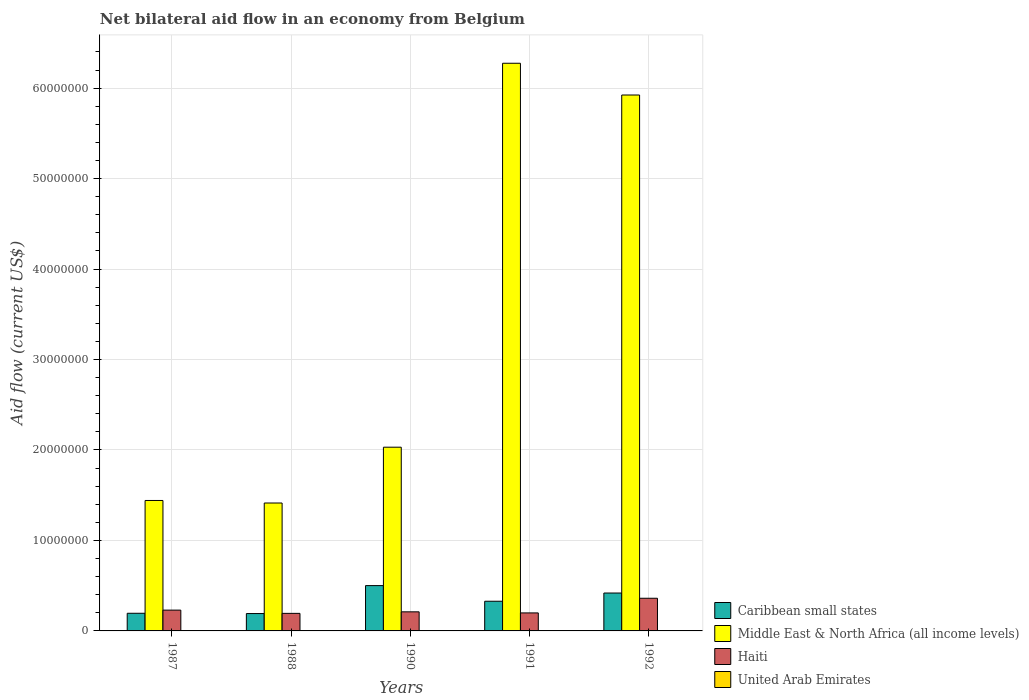How many groups of bars are there?
Offer a terse response. 5. Are the number of bars per tick equal to the number of legend labels?
Provide a succinct answer. Yes. Are the number of bars on each tick of the X-axis equal?
Offer a very short reply. Yes. How many bars are there on the 5th tick from the right?
Your answer should be very brief. 4. In how many cases, is the number of bars for a given year not equal to the number of legend labels?
Make the answer very short. 0. Across all years, what is the minimum net bilateral aid flow in Middle East & North Africa (all income levels)?
Provide a succinct answer. 1.41e+07. In which year was the net bilateral aid flow in United Arab Emirates maximum?
Your response must be concise. 1992. In which year was the net bilateral aid flow in Middle East & North Africa (all income levels) minimum?
Your answer should be very brief. 1988. What is the difference between the net bilateral aid flow in Caribbean small states in 1987 and that in 1992?
Provide a succinct answer. -2.24e+06. What is the difference between the net bilateral aid flow in Middle East & North Africa (all income levels) in 1988 and the net bilateral aid flow in Caribbean small states in 1991?
Provide a succinct answer. 1.09e+07. What is the average net bilateral aid flow in Caribbean small states per year?
Your response must be concise. 3.27e+06. In the year 1991, what is the difference between the net bilateral aid flow in Caribbean small states and net bilateral aid flow in Haiti?
Give a very brief answer. 1.29e+06. In how many years, is the net bilateral aid flow in Haiti greater than 24000000 US$?
Provide a succinct answer. 0. What is the difference between the highest and the second highest net bilateral aid flow in Middle East & North Africa (all income levels)?
Ensure brevity in your answer.  3.51e+06. What is the difference between the highest and the lowest net bilateral aid flow in United Arab Emirates?
Provide a short and direct response. 2.00e+04. In how many years, is the net bilateral aid flow in Caribbean small states greater than the average net bilateral aid flow in Caribbean small states taken over all years?
Your answer should be compact. 3. Is it the case that in every year, the sum of the net bilateral aid flow in United Arab Emirates and net bilateral aid flow in Middle East & North Africa (all income levels) is greater than the sum of net bilateral aid flow in Haiti and net bilateral aid flow in Caribbean small states?
Your answer should be compact. Yes. What does the 4th bar from the left in 1987 represents?
Ensure brevity in your answer.  United Arab Emirates. What does the 4th bar from the right in 1990 represents?
Your answer should be compact. Caribbean small states. Is it the case that in every year, the sum of the net bilateral aid flow in Middle East & North Africa (all income levels) and net bilateral aid flow in United Arab Emirates is greater than the net bilateral aid flow in Haiti?
Ensure brevity in your answer.  Yes. How many years are there in the graph?
Provide a short and direct response. 5. What is the difference between two consecutive major ticks on the Y-axis?
Your response must be concise. 1.00e+07. Are the values on the major ticks of Y-axis written in scientific E-notation?
Give a very brief answer. No. Does the graph contain grids?
Make the answer very short. Yes. Where does the legend appear in the graph?
Offer a very short reply. Bottom right. What is the title of the graph?
Provide a succinct answer. Net bilateral aid flow in an economy from Belgium. Does "Burkina Faso" appear as one of the legend labels in the graph?
Your answer should be very brief. No. What is the Aid flow (current US$) in Caribbean small states in 1987?
Offer a very short reply. 1.95e+06. What is the Aid flow (current US$) in Middle East & North Africa (all income levels) in 1987?
Your response must be concise. 1.44e+07. What is the Aid flow (current US$) of Haiti in 1987?
Make the answer very short. 2.30e+06. What is the Aid flow (current US$) of United Arab Emirates in 1987?
Keep it short and to the point. 10000. What is the Aid flow (current US$) in Caribbean small states in 1988?
Provide a short and direct response. 1.92e+06. What is the Aid flow (current US$) in Middle East & North Africa (all income levels) in 1988?
Give a very brief answer. 1.41e+07. What is the Aid flow (current US$) of Haiti in 1988?
Offer a very short reply. 1.94e+06. What is the Aid flow (current US$) in United Arab Emirates in 1988?
Keep it short and to the point. 10000. What is the Aid flow (current US$) in Caribbean small states in 1990?
Your answer should be very brief. 5.01e+06. What is the Aid flow (current US$) in Middle East & North Africa (all income levels) in 1990?
Provide a succinct answer. 2.03e+07. What is the Aid flow (current US$) of Haiti in 1990?
Ensure brevity in your answer.  2.11e+06. What is the Aid flow (current US$) of United Arab Emirates in 1990?
Provide a short and direct response. 10000. What is the Aid flow (current US$) of Caribbean small states in 1991?
Offer a terse response. 3.28e+06. What is the Aid flow (current US$) of Middle East & North Africa (all income levels) in 1991?
Provide a succinct answer. 6.28e+07. What is the Aid flow (current US$) of Haiti in 1991?
Your answer should be very brief. 1.99e+06. What is the Aid flow (current US$) in Caribbean small states in 1992?
Keep it short and to the point. 4.19e+06. What is the Aid flow (current US$) in Middle East & North Africa (all income levels) in 1992?
Provide a short and direct response. 5.92e+07. What is the Aid flow (current US$) of Haiti in 1992?
Your answer should be compact. 3.61e+06. Across all years, what is the maximum Aid flow (current US$) of Caribbean small states?
Keep it short and to the point. 5.01e+06. Across all years, what is the maximum Aid flow (current US$) of Middle East & North Africa (all income levels)?
Your response must be concise. 6.28e+07. Across all years, what is the maximum Aid flow (current US$) of Haiti?
Your response must be concise. 3.61e+06. Across all years, what is the maximum Aid flow (current US$) in United Arab Emirates?
Ensure brevity in your answer.  3.00e+04. Across all years, what is the minimum Aid flow (current US$) of Caribbean small states?
Provide a short and direct response. 1.92e+06. Across all years, what is the minimum Aid flow (current US$) in Middle East & North Africa (all income levels)?
Your answer should be very brief. 1.41e+07. Across all years, what is the minimum Aid flow (current US$) in Haiti?
Provide a succinct answer. 1.94e+06. Across all years, what is the minimum Aid flow (current US$) in United Arab Emirates?
Provide a succinct answer. 10000. What is the total Aid flow (current US$) of Caribbean small states in the graph?
Offer a terse response. 1.64e+07. What is the total Aid flow (current US$) of Middle East & North Africa (all income levels) in the graph?
Give a very brief answer. 1.71e+08. What is the total Aid flow (current US$) of Haiti in the graph?
Give a very brief answer. 1.20e+07. What is the total Aid flow (current US$) of United Arab Emirates in the graph?
Offer a very short reply. 7.00e+04. What is the difference between the Aid flow (current US$) in Caribbean small states in 1987 and that in 1988?
Give a very brief answer. 3.00e+04. What is the difference between the Aid flow (current US$) in Haiti in 1987 and that in 1988?
Ensure brevity in your answer.  3.60e+05. What is the difference between the Aid flow (current US$) in United Arab Emirates in 1987 and that in 1988?
Make the answer very short. 0. What is the difference between the Aid flow (current US$) of Caribbean small states in 1987 and that in 1990?
Provide a short and direct response. -3.06e+06. What is the difference between the Aid flow (current US$) of Middle East & North Africa (all income levels) in 1987 and that in 1990?
Your answer should be very brief. -5.89e+06. What is the difference between the Aid flow (current US$) of Haiti in 1987 and that in 1990?
Provide a succinct answer. 1.90e+05. What is the difference between the Aid flow (current US$) in Caribbean small states in 1987 and that in 1991?
Ensure brevity in your answer.  -1.33e+06. What is the difference between the Aid flow (current US$) in Middle East & North Africa (all income levels) in 1987 and that in 1991?
Your response must be concise. -4.83e+07. What is the difference between the Aid flow (current US$) in United Arab Emirates in 1987 and that in 1991?
Offer a terse response. 0. What is the difference between the Aid flow (current US$) of Caribbean small states in 1987 and that in 1992?
Make the answer very short. -2.24e+06. What is the difference between the Aid flow (current US$) of Middle East & North Africa (all income levels) in 1987 and that in 1992?
Provide a short and direct response. -4.48e+07. What is the difference between the Aid flow (current US$) of Haiti in 1987 and that in 1992?
Provide a short and direct response. -1.31e+06. What is the difference between the Aid flow (current US$) in United Arab Emirates in 1987 and that in 1992?
Your response must be concise. -2.00e+04. What is the difference between the Aid flow (current US$) in Caribbean small states in 1988 and that in 1990?
Offer a terse response. -3.09e+06. What is the difference between the Aid flow (current US$) in Middle East & North Africa (all income levels) in 1988 and that in 1990?
Your answer should be very brief. -6.17e+06. What is the difference between the Aid flow (current US$) of Caribbean small states in 1988 and that in 1991?
Keep it short and to the point. -1.36e+06. What is the difference between the Aid flow (current US$) of Middle East & North Africa (all income levels) in 1988 and that in 1991?
Your response must be concise. -4.86e+07. What is the difference between the Aid flow (current US$) of Haiti in 1988 and that in 1991?
Keep it short and to the point. -5.00e+04. What is the difference between the Aid flow (current US$) in United Arab Emirates in 1988 and that in 1991?
Give a very brief answer. 0. What is the difference between the Aid flow (current US$) of Caribbean small states in 1988 and that in 1992?
Your answer should be very brief. -2.27e+06. What is the difference between the Aid flow (current US$) in Middle East & North Africa (all income levels) in 1988 and that in 1992?
Keep it short and to the point. -4.51e+07. What is the difference between the Aid flow (current US$) in Haiti in 1988 and that in 1992?
Make the answer very short. -1.67e+06. What is the difference between the Aid flow (current US$) of Caribbean small states in 1990 and that in 1991?
Your response must be concise. 1.73e+06. What is the difference between the Aid flow (current US$) of Middle East & North Africa (all income levels) in 1990 and that in 1991?
Offer a very short reply. -4.24e+07. What is the difference between the Aid flow (current US$) of Haiti in 1990 and that in 1991?
Your answer should be very brief. 1.20e+05. What is the difference between the Aid flow (current US$) of United Arab Emirates in 1990 and that in 1991?
Offer a terse response. 0. What is the difference between the Aid flow (current US$) of Caribbean small states in 1990 and that in 1992?
Provide a short and direct response. 8.20e+05. What is the difference between the Aid flow (current US$) in Middle East & North Africa (all income levels) in 1990 and that in 1992?
Make the answer very short. -3.89e+07. What is the difference between the Aid flow (current US$) of Haiti in 1990 and that in 1992?
Your response must be concise. -1.50e+06. What is the difference between the Aid flow (current US$) in Caribbean small states in 1991 and that in 1992?
Offer a very short reply. -9.10e+05. What is the difference between the Aid flow (current US$) of Middle East & North Africa (all income levels) in 1991 and that in 1992?
Your answer should be compact. 3.51e+06. What is the difference between the Aid flow (current US$) in Haiti in 1991 and that in 1992?
Provide a succinct answer. -1.62e+06. What is the difference between the Aid flow (current US$) in United Arab Emirates in 1991 and that in 1992?
Keep it short and to the point. -2.00e+04. What is the difference between the Aid flow (current US$) of Caribbean small states in 1987 and the Aid flow (current US$) of Middle East & North Africa (all income levels) in 1988?
Your answer should be very brief. -1.22e+07. What is the difference between the Aid flow (current US$) of Caribbean small states in 1987 and the Aid flow (current US$) of United Arab Emirates in 1988?
Your answer should be compact. 1.94e+06. What is the difference between the Aid flow (current US$) of Middle East & North Africa (all income levels) in 1987 and the Aid flow (current US$) of Haiti in 1988?
Keep it short and to the point. 1.25e+07. What is the difference between the Aid flow (current US$) in Middle East & North Africa (all income levels) in 1987 and the Aid flow (current US$) in United Arab Emirates in 1988?
Give a very brief answer. 1.44e+07. What is the difference between the Aid flow (current US$) of Haiti in 1987 and the Aid flow (current US$) of United Arab Emirates in 1988?
Keep it short and to the point. 2.29e+06. What is the difference between the Aid flow (current US$) of Caribbean small states in 1987 and the Aid flow (current US$) of Middle East & North Africa (all income levels) in 1990?
Your answer should be very brief. -1.84e+07. What is the difference between the Aid flow (current US$) in Caribbean small states in 1987 and the Aid flow (current US$) in Haiti in 1990?
Offer a very short reply. -1.60e+05. What is the difference between the Aid flow (current US$) in Caribbean small states in 1987 and the Aid flow (current US$) in United Arab Emirates in 1990?
Provide a succinct answer. 1.94e+06. What is the difference between the Aid flow (current US$) in Middle East & North Africa (all income levels) in 1987 and the Aid flow (current US$) in Haiti in 1990?
Your answer should be very brief. 1.23e+07. What is the difference between the Aid flow (current US$) in Middle East & North Africa (all income levels) in 1987 and the Aid flow (current US$) in United Arab Emirates in 1990?
Provide a succinct answer. 1.44e+07. What is the difference between the Aid flow (current US$) in Haiti in 1987 and the Aid flow (current US$) in United Arab Emirates in 1990?
Offer a very short reply. 2.29e+06. What is the difference between the Aid flow (current US$) in Caribbean small states in 1987 and the Aid flow (current US$) in Middle East & North Africa (all income levels) in 1991?
Keep it short and to the point. -6.08e+07. What is the difference between the Aid flow (current US$) of Caribbean small states in 1987 and the Aid flow (current US$) of Haiti in 1991?
Offer a terse response. -4.00e+04. What is the difference between the Aid flow (current US$) in Caribbean small states in 1987 and the Aid flow (current US$) in United Arab Emirates in 1991?
Give a very brief answer. 1.94e+06. What is the difference between the Aid flow (current US$) of Middle East & North Africa (all income levels) in 1987 and the Aid flow (current US$) of Haiti in 1991?
Keep it short and to the point. 1.24e+07. What is the difference between the Aid flow (current US$) in Middle East & North Africa (all income levels) in 1987 and the Aid flow (current US$) in United Arab Emirates in 1991?
Your answer should be very brief. 1.44e+07. What is the difference between the Aid flow (current US$) of Haiti in 1987 and the Aid flow (current US$) of United Arab Emirates in 1991?
Your answer should be compact. 2.29e+06. What is the difference between the Aid flow (current US$) of Caribbean small states in 1987 and the Aid flow (current US$) of Middle East & North Africa (all income levels) in 1992?
Offer a terse response. -5.73e+07. What is the difference between the Aid flow (current US$) in Caribbean small states in 1987 and the Aid flow (current US$) in Haiti in 1992?
Make the answer very short. -1.66e+06. What is the difference between the Aid flow (current US$) of Caribbean small states in 1987 and the Aid flow (current US$) of United Arab Emirates in 1992?
Your answer should be very brief. 1.92e+06. What is the difference between the Aid flow (current US$) of Middle East & North Africa (all income levels) in 1987 and the Aid flow (current US$) of Haiti in 1992?
Give a very brief answer. 1.08e+07. What is the difference between the Aid flow (current US$) of Middle East & North Africa (all income levels) in 1987 and the Aid flow (current US$) of United Arab Emirates in 1992?
Provide a succinct answer. 1.44e+07. What is the difference between the Aid flow (current US$) of Haiti in 1987 and the Aid flow (current US$) of United Arab Emirates in 1992?
Offer a terse response. 2.27e+06. What is the difference between the Aid flow (current US$) of Caribbean small states in 1988 and the Aid flow (current US$) of Middle East & North Africa (all income levels) in 1990?
Offer a terse response. -1.84e+07. What is the difference between the Aid flow (current US$) of Caribbean small states in 1988 and the Aid flow (current US$) of Haiti in 1990?
Give a very brief answer. -1.90e+05. What is the difference between the Aid flow (current US$) in Caribbean small states in 1988 and the Aid flow (current US$) in United Arab Emirates in 1990?
Offer a terse response. 1.91e+06. What is the difference between the Aid flow (current US$) of Middle East & North Africa (all income levels) in 1988 and the Aid flow (current US$) of Haiti in 1990?
Ensure brevity in your answer.  1.20e+07. What is the difference between the Aid flow (current US$) in Middle East & North Africa (all income levels) in 1988 and the Aid flow (current US$) in United Arab Emirates in 1990?
Make the answer very short. 1.41e+07. What is the difference between the Aid flow (current US$) in Haiti in 1988 and the Aid flow (current US$) in United Arab Emirates in 1990?
Offer a very short reply. 1.93e+06. What is the difference between the Aid flow (current US$) of Caribbean small states in 1988 and the Aid flow (current US$) of Middle East & North Africa (all income levels) in 1991?
Ensure brevity in your answer.  -6.08e+07. What is the difference between the Aid flow (current US$) of Caribbean small states in 1988 and the Aid flow (current US$) of Haiti in 1991?
Offer a very short reply. -7.00e+04. What is the difference between the Aid flow (current US$) of Caribbean small states in 1988 and the Aid flow (current US$) of United Arab Emirates in 1991?
Keep it short and to the point. 1.91e+06. What is the difference between the Aid flow (current US$) in Middle East & North Africa (all income levels) in 1988 and the Aid flow (current US$) in Haiti in 1991?
Your response must be concise. 1.22e+07. What is the difference between the Aid flow (current US$) in Middle East & North Africa (all income levels) in 1988 and the Aid flow (current US$) in United Arab Emirates in 1991?
Your response must be concise. 1.41e+07. What is the difference between the Aid flow (current US$) of Haiti in 1988 and the Aid flow (current US$) of United Arab Emirates in 1991?
Your response must be concise. 1.93e+06. What is the difference between the Aid flow (current US$) of Caribbean small states in 1988 and the Aid flow (current US$) of Middle East & North Africa (all income levels) in 1992?
Make the answer very short. -5.73e+07. What is the difference between the Aid flow (current US$) in Caribbean small states in 1988 and the Aid flow (current US$) in Haiti in 1992?
Provide a short and direct response. -1.69e+06. What is the difference between the Aid flow (current US$) in Caribbean small states in 1988 and the Aid flow (current US$) in United Arab Emirates in 1992?
Ensure brevity in your answer.  1.89e+06. What is the difference between the Aid flow (current US$) in Middle East & North Africa (all income levels) in 1988 and the Aid flow (current US$) in Haiti in 1992?
Offer a very short reply. 1.05e+07. What is the difference between the Aid flow (current US$) in Middle East & North Africa (all income levels) in 1988 and the Aid flow (current US$) in United Arab Emirates in 1992?
Provide a short and direct response. 1.41e+07. What is the difference between the Aid flow (current US$) of Haiti in 1988 and the Aid flow (current US$) of United Arab Emirates in 1992?
Provide a succinct answer. 1.91e+06. What is the difference between the Aid flow (current US$) in Caribbean small states in 1990 and the Aid flow (current US$) in Middle East & North Africa (all income levels) in 1991?
Provide a succinct answer. -5.77e+07. What is the difference between the Aid flow (current US$) of Caribbean small states in 1990 and the Aid flow (current US$) of Haiti in 1991?
Keep it short and to the point. 3.02e+06. What is the difference between the Aid flow (current US$) of Middle East & North Africa (all income levels) in 1990 and the Aid flow (current US$) of Haiti in 1991?
Offer a terse response. 1.83e+07. What is the difference between the Aid flow (current US$) in Middle East & North Africa (all income levels) in 1990 and the Aid flow (current US$) in United Arab Emirates in 1991?
Make the answer very short. 2.03e+07. What is the difference between the Aid flow (current US$) of Haiti in 1990 and the Aid flow (current US$) of United Arab Emirates in 1991?
Ensure brevity in your answer.  2.10e+06. What is the difference between the Aid flow (current US$) in Caribbean small states in 1990 and the Aid flow (current US$) in Middle East & North Africa (all income levels) in 1992?
Keep it short and to the point. -5.42e+07. What is the difference between the Aid flow (current US$) of Caribbean small states in 1990 and the Aid flow (current US$) of Haiti in 1992?
Provide a short and direct response. 1.40e+06. What is the difference between the Aid flow (current US$) in Caribbean small states in 1990 and the Aid flow (current US$) in United Arab Emirates in 1992?
Your response must be concise. 4.98e+06. What is the difference between the Aid flow (current US$) in Middle East & North Africa (all income levels) in 1990 and the Aid flow (current US$) in Haiti in 1992?
Provide a short and direct response. 1.67e+07. What is the difference between the Aid flow (current US$) in Middle East & North Africa (all income levels) in 1990 and the Aid flow (current US$) in United Arab Emirates in 1992?
Offer a terse response. 2.03e+07. What is the difference between the Aid flow (current US$) in Haiti in 1990 and the Aid flow (current US$) in United Arab Emirates in 1992?
Make the answer very short. 2.08e+06. What is the difference between the Aid flow (current US$) of Caribbean small states in 1991 and the Aid flow (current US$) of Middle East & North Africa (all income levels) in 1992?
Offer a very short reply. -5.60e+07. What is the difference between the Aid flow (current US$) of Caribbean small states in 1991 and the Aid flow (current US$) of Haiti in 1992?
Provide a short and direct response. -3.30e+05. What is the difference between the Aid flow (current US$) in Caribbean small states in 1991 and the Aid flow (current US$) in United Arab Emirates in 1992?
Your answer should be very brief. 3.25e+06. What is the difference between the Aid flow (current US$) in Middle East & North Africa (all income levels) in 1991 and the Aid flow (current US$) in Haiti in 1992?
Make the answer very short. 5.91e+07. What is the difference between the Aid flow (current US$) in Middle East & North Africa (all income levels) in 1991 and the Aid flow (current US$) in United Arab Emirates in 1992?
Make the answer very short. 6.27e+07. What is the difference between the Aid flow (current US$) in Haiti in 1991 and the Aid flow (current US$) in United Arab Emirates in 1992?
Your answer should be very brief. 1.96e+06. What is the average Aid flow (current US$) of Caribbean small states per year?
Offer a very short reply. 3.27e+06. What is the average Aid flow (current US$) in Middle East & North Africa (all income levels) per year?
Your answer should be compact. 3.42e+07. What is the average Aid flow (current US$) in Haiti per year?
Your response must be concise. 2.39e+06. What is the average Aid flow (current US$) of United Arab Emirates per year?
Your answer should be compact. 1.40e+04. In the year 1987, what is the difference between the Aid flow (current US$) of Caribbean small states and Aid flow (current US$) of Middle East & North Africa (all income levels)?
Give a very brief answer. -1.25e+07. In the year 1987, what is the difference between the Aid flow (current US$) of Caribbean small states and Aid flow (current US$) of Haiti?
Make the answer very short. -3.50e+05. In the year 1987, what is the difference between the Aid flow (current US$) in Caribbean small states and Aid flow (current US$) in United Arab Emirates?
Ensure brevity in your answer.  1.94e+06. In the year 1987, what is the difference between the Aid flow (current US$) in Middle East & North Africa (all income levels) and Aid flow (current US$) in Haiti?
Your response must be concise. 1.21e+07. In the year 1987, what is the difference between the Aid flow (current US$) in Middle East & North Africa (all income levels) and Aid flow (current US$) in United Arab Emirates?
Keep it short and to the point. 1.44e+07. In the year 1987, what is the difference between the Aid flow (current US$) in Haiti and Aid flow (current US$) in United Arab Emirates?
Your answer should be compact. 2.29e+06. In the year 1988, what is the difference between the Aid flow (current US$) of Caribbean small states and Aid flow (current US$) of Middle East & North Africa (all income levels)?
Give a very brief answer. -1.22e+07. In the year 1988, what is the difference between the Aid flow (current US$) of Caribbean small states and Aid flow (current US$) of United Arab Emirates?
Make the answer very short. 1.91e+06. In the year 1988, what is the difference between the Aid flow (current US$) in Middle East & North Africa (all income levels) and Aid flow (current US$) in Haiti?
Provide a succinct answer. 1.22e+07. In the year 1988, what is the difference between the Aid flow (current US$) in Middle East & North Africa (all income levels) and Aid flow (current US$) in United Arab Emirates?
Your response must be concise. 1.41e+07. In the year 1988, what is the difference between the Aid flow (current US$) of Haiti and Aid flow (current US$) of United Arab Emirates?
Give a very brief answer. 1.93e+06. In the year 1990, what is the difference between the Aid flow (current US$) of Caribbean small states and Aid flow (current US$) of Middle East & North Africa (all income levels)?
Keep it short and to the point. -1.53e+07. In the year 1990, what is the difference between the Aid flow (current US$) in Caribbean small states and Aid flow (current US$) in Haiti?
Your answer should be very brief. 2.90e+06. In the year 1990, what is the difference between the Aid flow (current US$) in Caribbean small states and Aid flow (current US$) in United Arab Emirates?
Keep it short and to the point. 5.00e+06. In the year 1990, what is the difference between the Aid flow (current US$) in Middle East & North Africa (all income levels) and Aid flow (current US$) in Haiti?
Make the answer very short. 1.82e+07. In the year 1990, what is the difference between the Aid flow (current US$) in Middle East & North Africa (all income levels) and Aid flow (current US$) in United Arab Emirates?
Provide a succinct answer. 2.03e+07. In the year 1990, what is the difference between the Aid flow (current US$) in Haiti and Aid flow (current US$) in United Arab Emirates?
Ensure brevity in your answer.  2.10e+06. In the year 1991, what is the difference between the Aid flow (current US$) in Caribbean small states and Aid flow (current US$) in Middle East & North Africa (all income levels)?
Give a very brief answer. -5.95e+07. In the year 1991, what is the difference between the Aid flow (current US$) in Caribbean small states and Aid flow (current US$) in Haiti?
Keep it short and to the point. 1.29e+06. In the year 1991, what is the difference between the Aid flow (current US$) of Caribbean small states and Aid flow (current US$) of United Arab Emirates?
Offer a terse response. 3.27e+06. In the year 1991, what is the difference between the Aid flow (current US$) of Middle East & North Africa (all income levels) and Aid flow (current US$) of Haiti?
Your response must be concise. 6.08e+07. In the year 1991, what is the difference between the Aid flow (current US$) of Middle East & North Africa (all income levels) and Aid flow (current US$) of United Arab Emirates?
Your answer should be very brief. 6.27e+07. In the year 1991, what is the difference between the Aid flow (current US$) in Haiti and Aid flow (current US$) in United Arab Emirates?
Keep it short and to the point. 1.98e+06. In the year 1992, what is the difference between the Aid flow (current US$) of Caribbean small states and Aid flow (current US$) of Middle East & North Africa (all income levels)?
Provide a succinct answer. -5.50e+07. In the year 1992, what is the difference between the Aid flow (current US$) of Caribbean small states and Aid flow (current US$) of Haiti?
Offer a terse response. 5.80e+05. In the year 1992, what is the difference between the Aid flow (current US$) of Caribbean small states and Aid flow (current US$) of United Arab Emirates?
Offer a very short reply. 4.16e+06. In the year 1992, what is the difference between the Aid flow (current US$) in Middle East & North Africa (all income levels) and Aid flow (current US$) in Haiti?
Provide a short and direct response. 5.56e+07. In the year 1992, what is the difference between the Aid flow (current US$) of Middle East & North Africa (all income levels) and Aid flow (current US$) of United Arab Emirates?
Your response must be concise. 5.92e+07. In the year 1992, what is the difference between the Aid flow (current US$) in Haiti and Aid flow (current US$) in United Arab Emirates?
Offer a terse response. 3.58e+06. What is the ratio of the Aid flow (current US$) in Caribbean small states in 1987 to that in 1988?
Provide a succinct answer. 1.02. What is the ratio of the Aid flow (current US$) in Middle East & North Africa (all income levels) in 1987 to that in 1988?
Offer a terse response. 1.02. What is the ratio of the Aid flow (current US$) in Haiti in 1987 to that in 1988?
Keep it short and to the point. 1.19. What is the ratio of the Aid flow (current US$) of Caribbean small states in 1987 to that in 1990?
Make the answer very short. 0.39. What is the ratio of the Aid flow (current US$) in Middle East & North Africa (all income levels) in 1987 to that in 1990?
Ensure brevity in your answer.  0.71. What is the ratio of the Aid flow (current US$) in Haiti in 1987 to that in 1990?
Your answer should be very brief. 1.09. What is the ratio of the Aid flow (current US$) in Caribbean small states in 1987 to that in 1991?
Offer a terse response. 0.59. What is the ratio of the Aid flow (current US$) in Middle East & North Africa (all income levels) in 1987 to that in 1991?
Ensure brevity in your answer.  0.23. What is the ratio of the Aid flow (current US$) of Haiti in 1987 to that in 1991?
Provide a succinct answer. 1.16. What is the ratio of the Aid flow (current US$) of Caribbean small states in 1987 to that in 1992?
Make the answer very short. 0.47. What is the ratio of the Aid flow (current US$) of Middle East & North Africa (all income levels) in 1987 to that in 1992?
Ensure brevity in your answer.  0.24. What is the ratio of the Aid flow (current US$) of Haiti in 1987 to that in 1992?
Offer a very short reply. 0.64. What is the ratio of the Aid flow (current US$) of United Arab Emirates in 1987 to that in 1992?
Make the answer very short. 0.33. What is the ratio of the Aid flow (current US$) in Caribbean small states in 1988 to that in 1990?
Ensure brevity in your answer.  0.38. What is the ratio of the Aid flow (current US$) of Middle East & North Africa (all income levels) in 1988 to that in 1990?
Give a very brief answer. 0.7. What is the ratio of the Aid flow (current US$) in Haiti in 1988 to that in 1990?
Provide a short and direct response. 0.92. What is the ratio of the Aid flow (current US$) of United Arab Emirates in 1988 to that in 1990?
Ensure brevity in your answer.  1. What is the ratio of the Aid flow (current US$) of Caribbean small states in 1988 to that in 1991?
Provide a short and direct response. 0.59. What is the ratio of the Aid flow (current US$) of Middle East & North Africa (all income levels) in 1988 to that in 1991?
Offer a very short reply. 0.23. What is the ratio of the Aid flow (current US$) in Haiti in 1988 to that in 1991?
Make the answer very short. 0.97. What is the ratio of the Aid flow (current US$) of United Arab Emirates in 1988 to that in 1991?
Your answer should be very brief. 1. What is the ratio of the Aid flow (current US$) in Caribbean small states in 1988 to that in 1992?
Make the answer very short. 0.46. What is the ratio of the Aid flow (current US$) of Middle East & North Africa (all income levels) in 1988 to that in 1992?
Provide a succinct answer. 0.24. What is the ratio of the Aid flow (current US$) in Haiti in 1988 to that in 1992?
Keep it short and to the point. 0.54. What is the ratio of the Aid flow (current US$) of Caribbean small states in 1990 to that in 1991?
Your answer should be compact. 1.53. What is the ratio of the Aid flow (current US$) in Middle East & North Africa (all income levels) in 1990 to that in 1991?
Ensure brevity in your answer.  0.32. What is the ratio of the Aid flow (current US$) of Haiti in 1990 to that in 1991?
Keep it short and to the point. 1.06. What is the ratio of the Aid flow (current US$) in United Arab Emirates in 1990 to that in 1991?
Give a very brief answer. 1. What is the ratio of the Aid flow (current US$) of Caribbean small states in 1990 to that in 1992?
Make the answer very short. 1.2. What is the ratio of the Aid flow (current US$) in Middle East & North Africa (all income levels) in 1990 to that in 1992?
Offer a very short reply. 0.34. What is the ratio of the Aid flow (current US$) of Haiti in 1990 to that in 1992?
Your response must be concise. 0.58. What is the ratio of the Aid flow (current US$) in United Arab Emirates in 1990 to that in 1992?
Offer a very short reply. 0.33. What is the ratio of the Aid flow (current US$) in Caribbean small states in 1991 to that in 1992?
Offer a terse response. 0.78. What is the ratio of the Aid flow (current US$) of Middle East & North Africa (all income levels) in 1991 to that in 1992?
Ensure brevity in your answer.  1.06. What is the ratio of the Aid flow (current US$) of Haiti in 1991 to that in 1992?
Keep it short and to the point. 0.55. What is the ratio of the Aid flow (current US$) of United Arab Emirates in 1991 to that in 1992?
Your answer should be compact. 0.33. What is the difference between the highest and the second highest Aid flow (current US$) in Caribbean small states?
Make the answer very short. 8.20e+05. What is the difference between the highest and the second highest Aid flow (current US$) in Middle East & North Africa (all income levels)?
Provide a short and direct response. 3.51e+06. What is the difference between the highest and the second highest Aid flow (current US$) in Haiti?
Provide a short and direct response. 1.31e+06. What is the difference between the highest and the lowest Aid flow (current US$) of Caribbean small states?
Keep it short and to the point. 3.09e+06. What is the difference between the highest and the lowest Aid flow (current US$) in Middle East & North Africa (all income levels)?
Make the answer very short. 4.86e+07. What is the difference between the highest and the lowest Aid flow (current US$) in Haiti?
Your answer should be compact. 1.67e+06. 